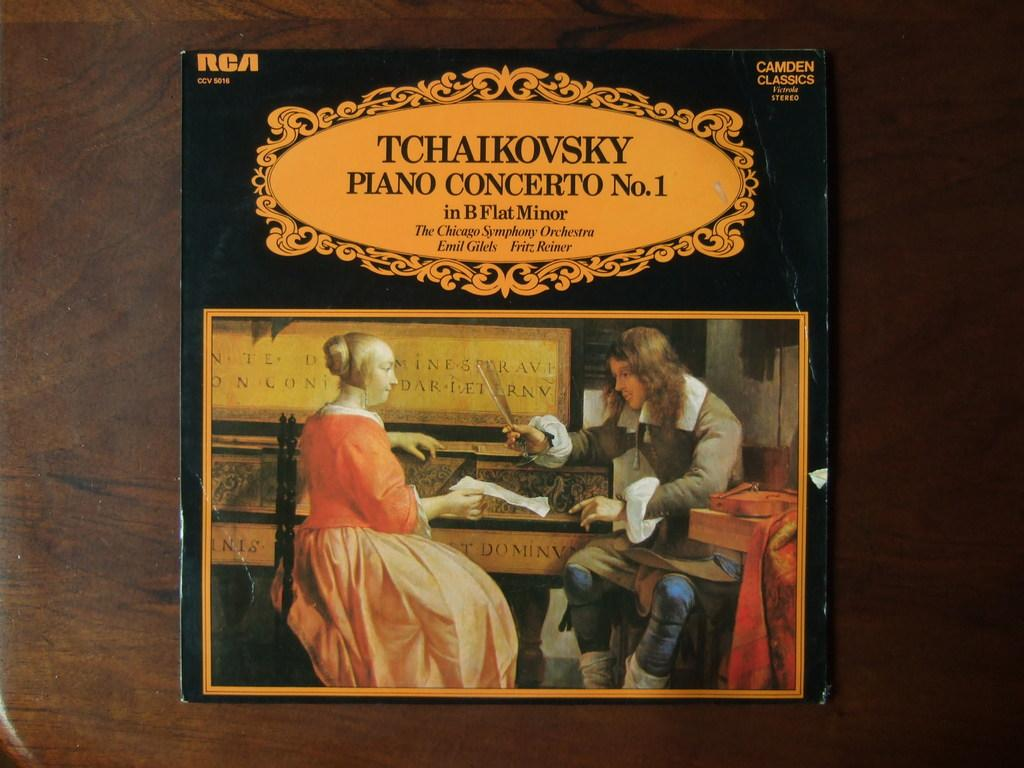Provide a one-sentence caption for the provided image. Tchaikovsky piano concerto record which is number one. 